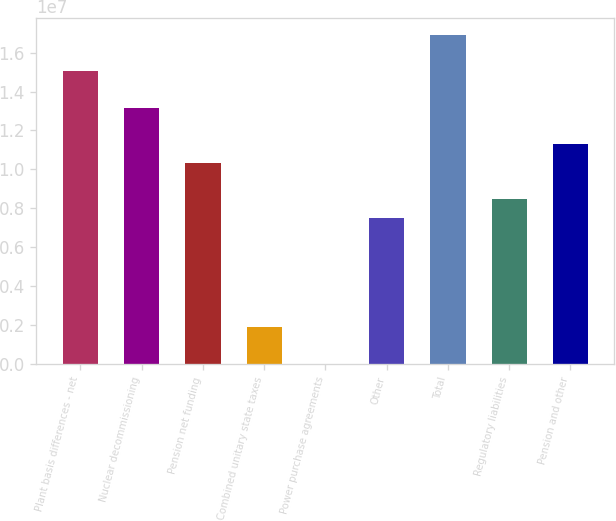<chart> <loc_0><loc_0><loc_500><loc_500><bar_chart><fcel>Plant basis differences - net<fcel>Nuclear decommissioning<fcel>Pension net funding<fcel>Combined unitary state taxes<fcel>Power purchase agreements<fcel>Other<fcel>Total<fcel>Regulatory liabilities<fcel>Pension and other<nl><fcel>1.50444e+07<fcel>1.3164e+07<fcel>1.03433e+07<fcel>1.88142e+06<fcel>993<fcel>7.5227e+06<fcel>1.69248e+07<fcel>8.46291e+06<fcel>1.12836e+07<nl></chart> 